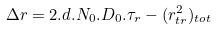<formula> <loc_0><loc_0><loc_500><loc_500>\Delta r = 2 . d . N _ { 0 } . D _ { 0 } . \tau _ { r } - ( r _ { t r } ^ { 2 } ) _ { t o t }</formula> 